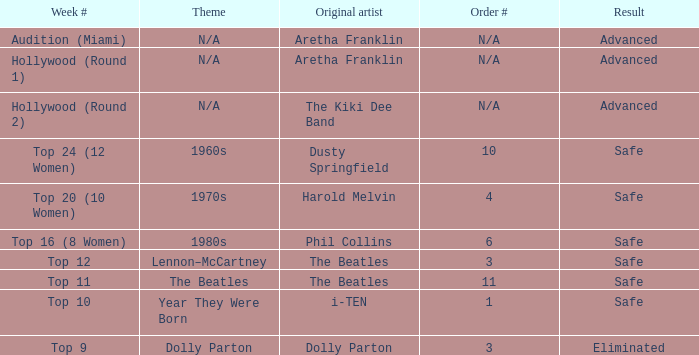What is the first artist of the top 9 during the week number? Dolly Parton. 